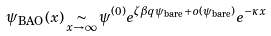<formula> <loc_0><loc_0><loc_500><loc_500>\psi _ { \text {BAO} } ( x ) \underset { x \to \infty } { \sim } \psi ^ { ( 0 ) } e ^ { \zeta \beta q \psi _ { \text {bare} } + o ( \psi _ { \text {bare} } ) } e ^ { - \kappa x }</formula> 